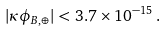<formula> <loc_0><loc_0><loc_500><loc_500>| \kappa \phi _ { B , \oplus } | < 3 . 7 \times 1 0 ^ { - 1 5 } \, .</formula> 